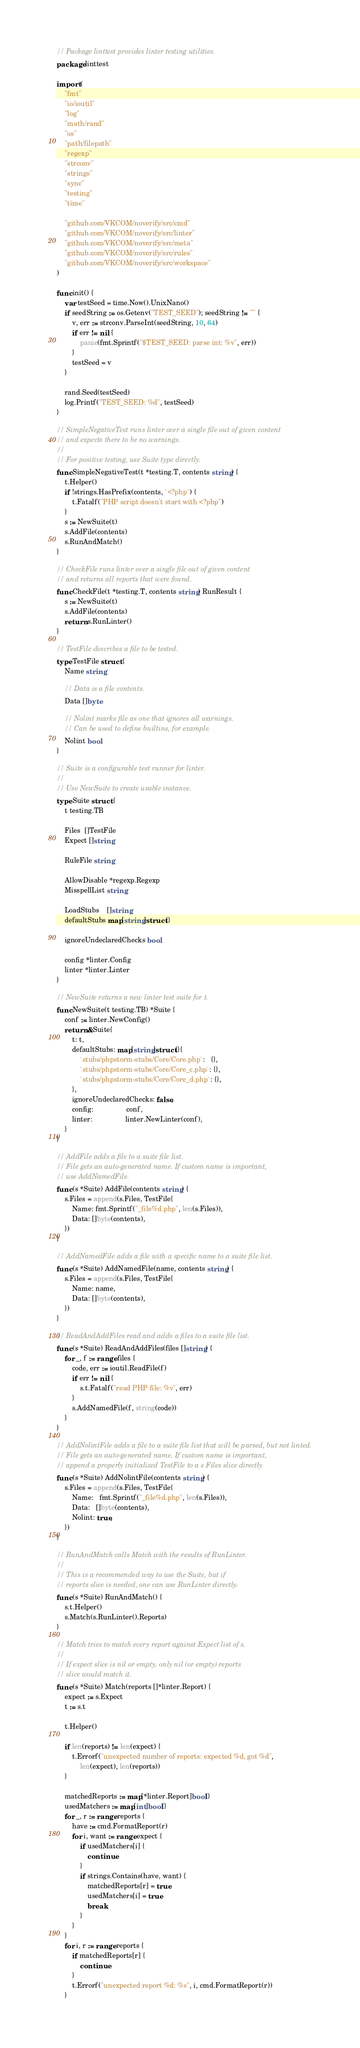Convert code to text. <code><loc_0><loc_0><loc_500><loc_500><_Go_>// Package linttest provides linter testing utilities.
package linttest

import (
	"fmt"
	"io/ioutil"
	"log"
	"math/rand"
	"os"
	"path/filepath"
	"regexp"
	"strconv"
	"strings"
	"sync"
	"testing"
	"time"

	"github.com/VKCOM/noverify/src/cmd"
	"github.com/VKCOM/noverify/src/linter"
	"github.com/VKCOM/noverify/src/meta"
	"github.com/VKCOM/noverify/src/rules"
	"github.com/VKCOM/noverify/src/workspace"
)

func init() {
	var testSeed = time.Now().UnixNano()
	if seedString := os.Getenv("TEST_SEED"); seedString != "" {
		v, err := strconv.ParseInt(seedString, 10, 64)
		if err != nil {
			panic(fmt.Sprintf("$TEST_SEED: parse int: %v", err))
		}
		testSeed = v
	}

	rand.Seed(testSeed)
	log.Printf("TEST_SEED: %d", testSeed)
}

// SimpleNegativeTest runs linter over a single file out of given content
// and expects there to be no warnings.
//
// For positive testing, use Suite type directly.
func SimpleNegativeTest(t *testing.T, contents string) {
	t.Helper()
	if !strings.HasPrefix(contents, `<?php`) {
		t.Fatalf("PHP script doesn't start with <?php")
	}
	s := NewSuite(t)
	s.AddFile(contents)
	s.RunAndMatch()
}

// CheckFile runs linter over a single file out of given content
// and returns all reports that were found.
func CheckFile(t *testing.T, contents string) RunResult {
	s := NewSuite(t)
	s.AddFile(contents)
	return s.RunLinter()
}

// TestFile describes a file to be tested.
type TestFile struct {
	Name string

	// Data is a file contents.
	Data []byte

	// Nolint marks file as one that ignores all warnings.
	// Can be used to define builtins, for example.
	Nolint bool
}

// Suite is a configurable test runner for linter.
//
// Use NewSuite to create usable instance.
type Suite struct {
	t testing.TB

	Files  []TestFile
	Expect []string

	RuleFile string

	AllowDisable *regexp.Regexp
	MisspellList string

	LoadStubs    []string
	defaultStubs map[string]struct{}

	ignoreUndeclaredChecks bool

	config *linter.Config
	linter *linter.Linter
}

// NewSuite returns a new linter test suite for t.
func NewSuite(t testing.TB) *Suite {
	conf := linter.NewConfig()
	return &Suite{
		t: t,
		defaultStubs: map[string]struct{}{
			`stubs/phpstorm-stubs/Core/Core.php`:   {},
			`stubs/phpstorm-stubs/Core/Core_c.php`: {},
			`stubs/phpstorm-stubs/Core/Core_d.php`: {},
		},
		ignoreUndeclaredChecks: false,
		config:                 conf,
		linter:                 linter.NewLinter(conf),
	}
}

// AddFile adds a file to a suite file list.
// File gets an auto-generated name. If custom name is important,
// use AddNamedFile.
func (s *Suite) AddFile(contents string) {
	s.Files = append(s.Files, TestFile{
		Name: fmt.Sprintf("_file%d.php", len(s.Files)),
		Data: []byte(contents),
	})
}

// AddNamedFile adds a file with a specific name to a suite file list.
func (s *Suite) AddNamedFile(name, contents string) {
	s.Files = append(s.Files, TestFile{
		Name: name,
		Data: []byte(contents),
	})
}

// ReadAndAddFiles read and adds a files to a suite file list.
func (s *Suite) ReadAndAddFiles(files []string) {
	for _, f := range files {
		code, err := ioutil.ReadFile(f)
		if err != nil {
			s.t.Fatalf("read PHP file: %v", err)
		}
		s.AddNamedFile(f, string(code))
	}
}

// AddNolintFile adds a file to a suite file list that will be parsed, but not linted.
// File gets an auto-generated name. If custom name is important,
// append a properly initialized TestFile to a s Files slice directly.
func (s *Suite) AddNolintFile(contents string) {
	s.Files = append(s.Files, TestFile{
		Name:   fmt.Sprintf("_file%d.php", len(s.Files)),
		Data:   []byte(contents),
		Nolint: true,
	})
}

// RunAndMatch calls Match with the results of RunLinter.
//
// This is a recommended way to use the Suite, but if
// reports slice is needed, one can use RunLinter directly.
func (s *Suite) RunAndMatch() {
	s.t.Helper()
	s.Match(s.RunLinter().Reports)
}

// Match tries to match every report against Expect list of s.
//
// If expect slice is nil or empty, only nil (or empty) reports
// slice would match it.
func (s *Suite) Match(reports []*linter.Report) {
	expect := s.Expect
	t := s.t

	t.Helper()

	if len(reports) != len(expect) {
		t.Errorf("unexpected number of reports: expected %d, got %d",
			len(expect), len(reports))
	}

	matchedReports := map[*linter.Report]bool{}
	usedMatchers := map[int]bool{}
	for _, r := range reports {
		have := cmd.FormatReport(r)
		for i, want := range expect {
			if usedMatchers[i] {
				continue
			}
			if strings.Contains(have, want) {
				matchedReports[r] = true
				usedMatchers[i] = true
				break
			}
		}
	}
	for i, r := range reports {
		if matchedReports[r] {
			continue
		}
		t.Errorf("unexpected report %d: %s", i, cmd.FormatReport(r))
	}</code> 